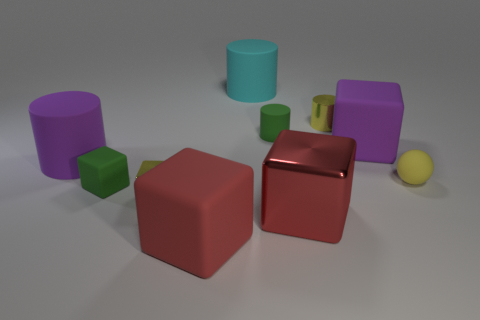Subtract all yellow cylinders. How many cylinders are left? 3 Subtract 1 cylinders. How many cylinders are left? 3 Subtract all red cubes. How many cubes are left? 3 Subtract all gray balls. How many red cubes are left? 2 Add 6 red objects. How many red objects exist? 8 Subtract 0 cyan spheres. How many objects are left? 10 Subtract all cylinders. How many objects are left? 6 Subtract all gray blocks. Subtract all green cylinders. How many blocks are left? 5 Subtract all large purple rubber things. Subtract all small rubber spheres. How many objects are left? 7 Add 7 matte blocks. How many matte blocks are left? 10 